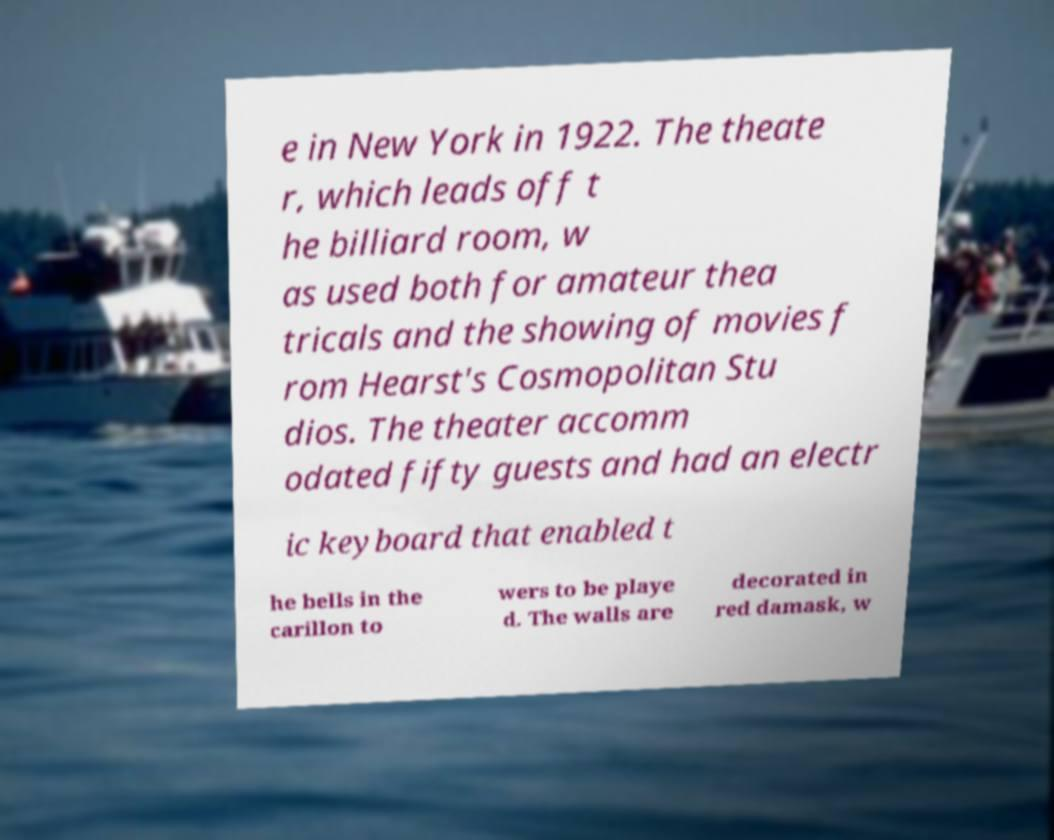What messages or text are displayed in this image? I need them in a readable, typed format. e in New York in 1922. The theate r, which leads off t he billiard room, w as used both for amateur thea tricals and the showing of movies f rom Hearst's Cosmopolitan Stu dios. The theater accomm odated fifty guests and had an electr ic keyboard that enabled t he bells in the carillon to wers to be playe d. The walls are decorated in red damask, w 